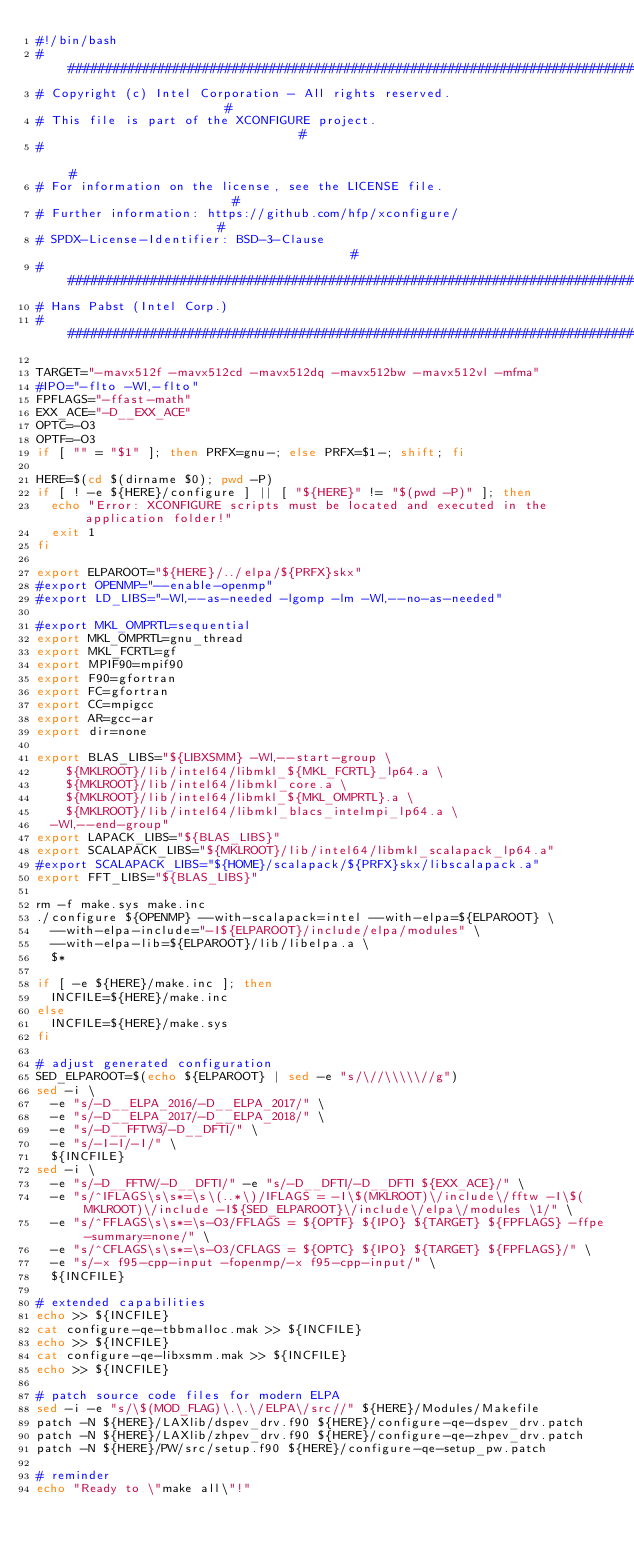Convert code to text. <code><loc_0><loc_0><loc_500><loc_500><_Bash_>#!/bin/bash
###############################################################################
# Copyright (c) Intel Corporation - All rights reserved.                      #
# This file is part of the XCONFIGURE project.                                #
#                                                                             #
# For information on the license, see the LICENSE file.                       #
# Further information: https://github.com/hfp/xconfigure/                     #
# SPDX-License-Identifier: BSD-3-Clause                                       #
###############################################################################
# Hans Pabst (Intel Corp.)
###############################################################################

TARGET="-mavx512f -mavx512cd -mavx512dq -mavx512bw -mavx512vl -mfma"
#IPO="-flto -Wl,-flto"
FPFLAGS="-ffast-math"
EXX_ACE="-D__EXX_ACE"
OPTC=-O3
OPTF=-O3
if [ "" = "$1" ]; then PRFX=gnu-; else PRFX=$1-; shift; fi

HERE=$(cd $(dirname $0); pwd -P)
if [ ! -e ${HERE}/configure ] || [ "${HERE}" != "$(pwd -P)" ]; then
  echo "Error: XCONFIGURE scripts must be located and executed in the application folder!"
  exit 1
fi

export ELPAROOT="${HERE}/../elpa/${PRFX}skx"
#export OPENMP="--enable-openmp"
#export LD_LIBS="-Wl,--as-needed -lgomp -lm -Wl,--no-as-needed"

#export MKL_OMPRTL=sequential
export MKL_OMPRTL=gnu_thread
export MKL_FCRTL=gf
export MPIF90=mpif90
export F90=gfortran
export FC=gfortran
export CC=mpigcc
export AR=gcc-ar
export dir=none

export BLAS_LIBS="${LIBXSMM} -Wl,--start-group \
    ${MKLROOT}/lib/intel64/libmkl_${MKL_FCRTL}_lp64.a \
    ${MKLROOT}/lib/intel64/libmkl_core.a \
    ${MKLROOT}/lib/intel64/libmkl_${MKL_OMPRTL}.a \
    ${MKLROOT}/lib/intel64/libmkl_blacs_intelmpi_lp64.a \
  -Wl,--end-group"
export LAPACK_LIBS="${BLAS_LIBS}"
export SCALAPACK_LIBS="${MKLROOT}/lib/intel64/libmkl_scalapack_lp64.a"
#export SCALAPACK_LIBS="${HOME}/scalapack/${PRFX}skx/libscalapack.a"
export FFT_LIBS="${BLAS_LIBS}"

rm -f make.sys make.inc
./configure ${OPENMP} --with-scalapack=intel --with-elpa=${ELPAROOT} \
  --with-elpa-include="-I${ELPAROOT}/include/elpa/modules" \
  --with-elpa-lib=${ELPAROOT}/lib/libelpa.a \
  $*

if [ -e ${HERE}/make.inc ]; then
  INCFILE=${HERE}/make.inc
else
  INCFILE=${HERE}/make.sys
fi

# adjust generated configuration
SED_ELPAROOT=$(echo ${ELPAROOT} | sed -e "s/\//\\\\\//g")
sed -i \
  -e "s/-D__ELPA_2016/-D__ELPA_2017/" \
  -e "s/-D__ELPA_2017/-D__ELPA_2018/" \
  -e "s/-D__FFTW3/-D__DFTI/" \
  -e "s/-I-I/-I/" \
  ${INCFILE}
sed -i \
  -e "s/-D__FFTW/-D__DFTI/" -e "s/-D__DFTI/-D__DFTI ${EXX_ACE}/" \
  -e "s/^IFLAGS\s\s*=\s\(..*\)/IFLAGS = -I\$(MKLROOT)\/include\/fftw -I\$(MKLROOT)\/include -I${SED_ELPAROOT}\/include\/elpa\/modules \1/" \
  -e "s/^FFLAGS\s\s*=\s-O3/FFLAGS = ${OPTF} ${IPO} ${TARGET} ${FPFLAGS} -ffpe-summary=none/" \
  -e "s/^CFLAGS\s\s*=\s-O3/CFLAGS = ${OPTC} ${IPO} ${TARGET} ${FPFLAGS}/" \
  -e "s/-x f95-cpp-input -fopenmp/-x f95-cpp-input/" \
  ${INCFILE}

# extended capabilities
echo >> ${INCFILE}
cat configure-qe-tbbmalloc.mak >> ${INCFILE}
echo >> ${INCFILE}
cat configure-qe-libxsmm.mak >> ${INCFILE}
echo >> ${INCFILE}

# patch source code files for modern ELPA
sed -i -e "s/\$(MOD_FLAG)\.\.\/ELPA\/src//" ${HERE}/Modules/Makefile
patch -N ${HERE}/LAXlib/dspev_drv.f90 ${HERE}/configure-qe-dspev_drv.patch
patch -N ${HERE}/LAXlib/zhpev_drv.f90 ${HERE}/configure-qe-zhpev_drv.patch
patch -N ${HERE}/PW/src/setup.f90 ${HERE}/configure-qe-setup_pw.patch

# reminder
echo "Ready to \"make all\"!"

</code> 